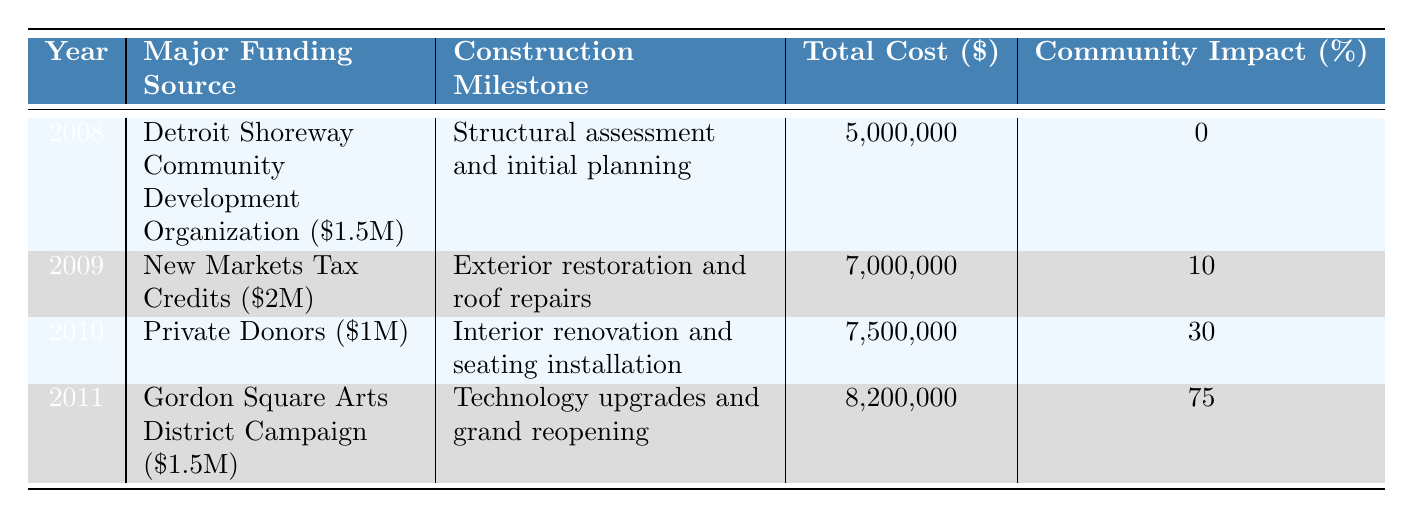What was the total renovation cost in 2011? The total cost for renovation in 2011 is stated directly in the table. The value is listed as $8,200,000.
Answer: $8,200,000 Which year had the highest community impact percentage? The community impact percentages for each year are listed in the table. In 2011, the percentage is 75, which is higher than all other years.
Answer: 2011 What is the main funding source for the renovation in 2009? The main funding source for 2009 is indicated in the table. It shows "New Markets Tax Credits" with a contribution of $2,000,000.
Answer: New Markets Tax Credits If we sum the total costs from 2008 to 2010, what is the result? The total costs for the years 2008, 2009, and 2010 are $5,000,000, $7,000,000, and $7,500,000, respectively. Summing these gives $5,000,000 + $7,000,000 + $7,500,000 = $19,500,000.
Answer: $19,500,000 Was there any community impact recorded in 2008? The table lists the community impact for 2008 as 0%. Thus, no impact was recorded in that year.
Answer: No Which year experienced the largest increase in total renovation cost from the previous year? The total costs for the years are: 2008: $5,000,000, 2009: $7,000,000, 2010: $7,500,000, 2011: $8,200,000. The increase from 2010 to 2011 is $700,000, but the increase from 2008 to 2009 is $2,000,000, which is larger.
Answer: 2009 What construction milestone was achieved in 2010? The table provides the construction milestone for 2010, which is "Interior renovation and seating installation."
Answer: Interior renovation and seating installation Which year had funding from the Cleveland Foundation, and how much was it? The Cleveland Foundation provided funding in 2009 for $500,000, as indicated in the funding sources for that year.
Answer: 2009, $500,000 How much did the State of Ohio Capital Budget contribute to the renovation? The State of Ohio Capital Budget contributed $1,000,000 to the renovation in 2011, as shown in the funding sources for that year.
Answer: $1,000,000 What was the growth in community impact from 2008 to 2011? The community impact in 2008 was 0% and in 2011 was 75%. The growth is calculated as 75 - 0 = 75%.
Answer: 75% 